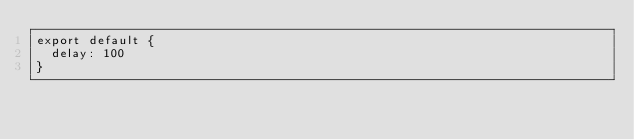<code> <loc_0><loc_0><loc_500><loc_500><_JavaScript_>export default {
  delay: 100
}
</code> 